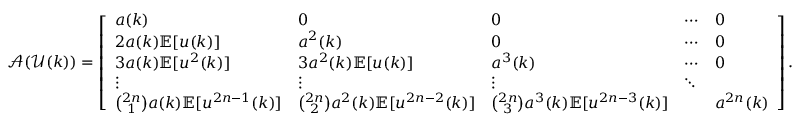Convert formula to latex. <formula><loc_0><loc_0><loc_500><loc_500>\ m a t h s c r { A } ( \ m a t h s c r { U } ( k ) ) = \left [ \begin{array} { l l l l l } { a ( k ) } & { 0 } & { 0 } & { \cdots } & { 0 } \\ { 2 a ( k ) \mathbb { E } [ u ( k ) ] } & { a ^ { 2 } ( k ) } & { 0 } & { \cdots } & { 0 } \\ { 3 a ( k ) \mathbb { E } [ u ^ { 2 } ( k ) ] } & { 3 a ^ { 2 } ( k ) \mathbb { E } [ u ( k ) ] } & { a ^ { 3 } ( k ) } & { \cdots } & { 0 } \\ { \vdots } & { \vdots } & { \vdots } & { \ddots } \\ { \binom { 2 n } { 1 } a ( k ) \mathbb { E } [ u ^ { 2 n - 1 } ( k ) ] } & { \binom { 2 n } { 2 } a ^ { 2 } ( k ) \mathbb { E } [ u ^ { 2 n - 2 } ( k ) ] } & { \binom { 2 n } { 3 } a ^ { 3 } ( k ) \mathbb { E } [ u ^ { 2 n - 3 } ( k ) ] } & & { a ^ { 2 n } ( k ) } \end{array} \right ] .</formula> 